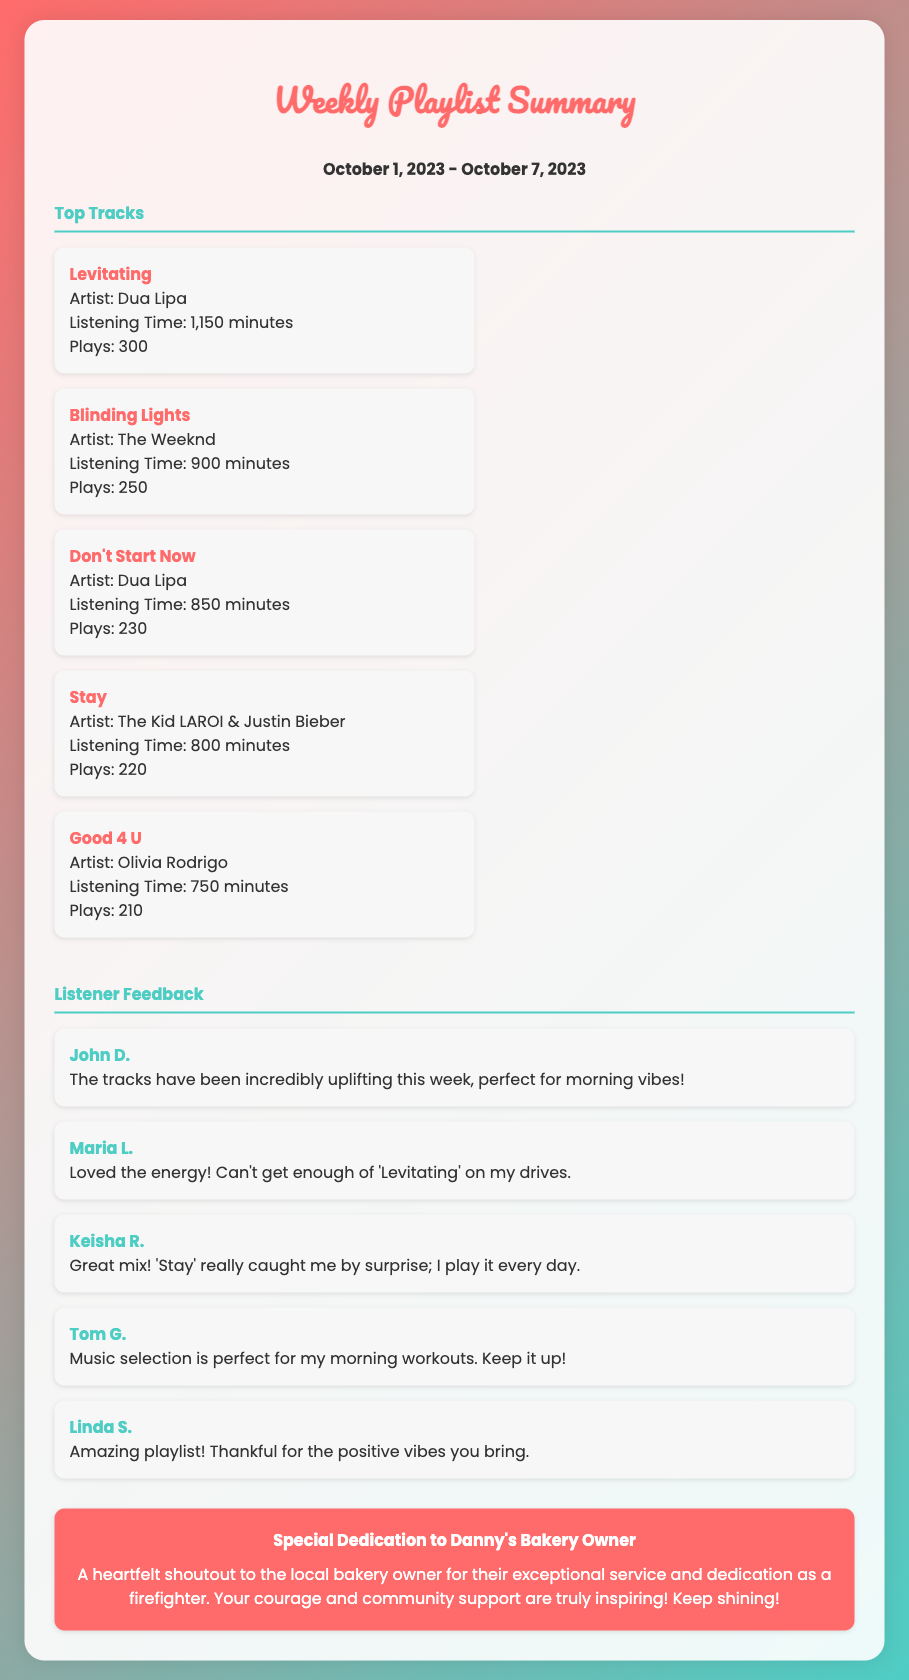What is the date range covered in the summary? The date range is specified at the top of the document. It indicates the period for which the playlist summary applies.
Answer: October 1, 2023 - October 7, 2023 Who is the artist of the track "Levitating"? This information is found in the 'Top Tracks' section, along with the corresponding artist for each track.
Answer: Dua Lipa How many plays did "Blinding Lights" receive? The number of plays for each track is detailed in the tracking section of the document.
Answer: 250 Which track has the highest listening time? This requires reasoning by comparing the listening times listed in the 'Top Tracks' section.
Answer: Levitating What was one piece of feedback from Linda S.? The feedback section contains direct comments from listeners, including their names and thoughts.
Answer: Amazing playlist! Thankful for the positive vibes you bring What is the special dedication about? The dedication section summarizes the sentiment expressed towards a local figure and their contributions.
Answer: A heartfelt shoutout to the local bakery owner for their exceptional service and dedication as a firefighter 